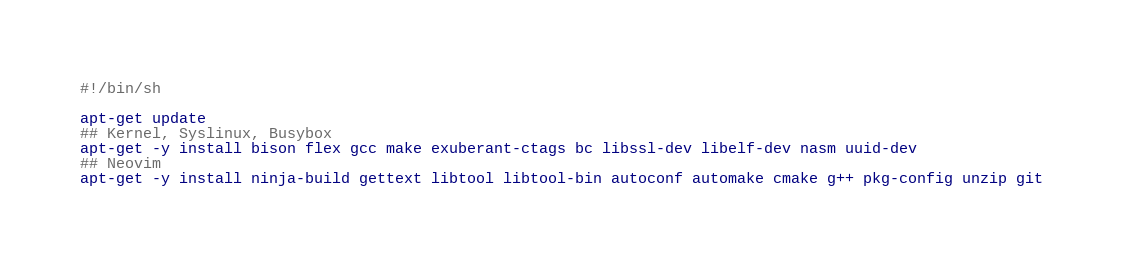Convert code to text. <code><loc_0><loc_0><loc_500><loc_500><_Bash_>#!/bin/sh

apt-get update
## Kernel, Syslinux, Busybox
apt-get -y install bison flex gcc make exuberant-ctags bc libssl-dev libelf-dev nasm uuid-dev
## Neovim
apt-get -y install ninja-build gettext libtool libtool-bin autoconf automake cmake g++ pkg-config unzip git</code> 